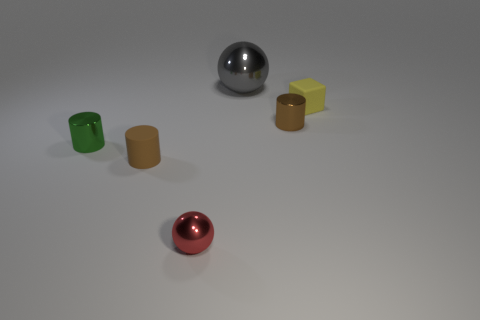Add 1 small green metallic cylinders. How many objects exist? 7 Subtract all green metallic cylinders. How many cylinders are left? 2 Subtract all gray balls. How many balls are left? 1 Subtract 0 cyan blocks. How many objects are left? 6 Subtract all cubes. How many objects are left? 5 Subtract 1 blocks. How many blocks are left? 0 Subtract all blue balls. Subtract all brown cylinders. How many balls are left? 2 Subtract all brown cylinders. How many blue blocks are left? 0 Subtract all small red rubber cylinders. Subtract all red spheres. How many objects are left? 5 Add 6 matte cubes. How many matte cubes are left? 7 